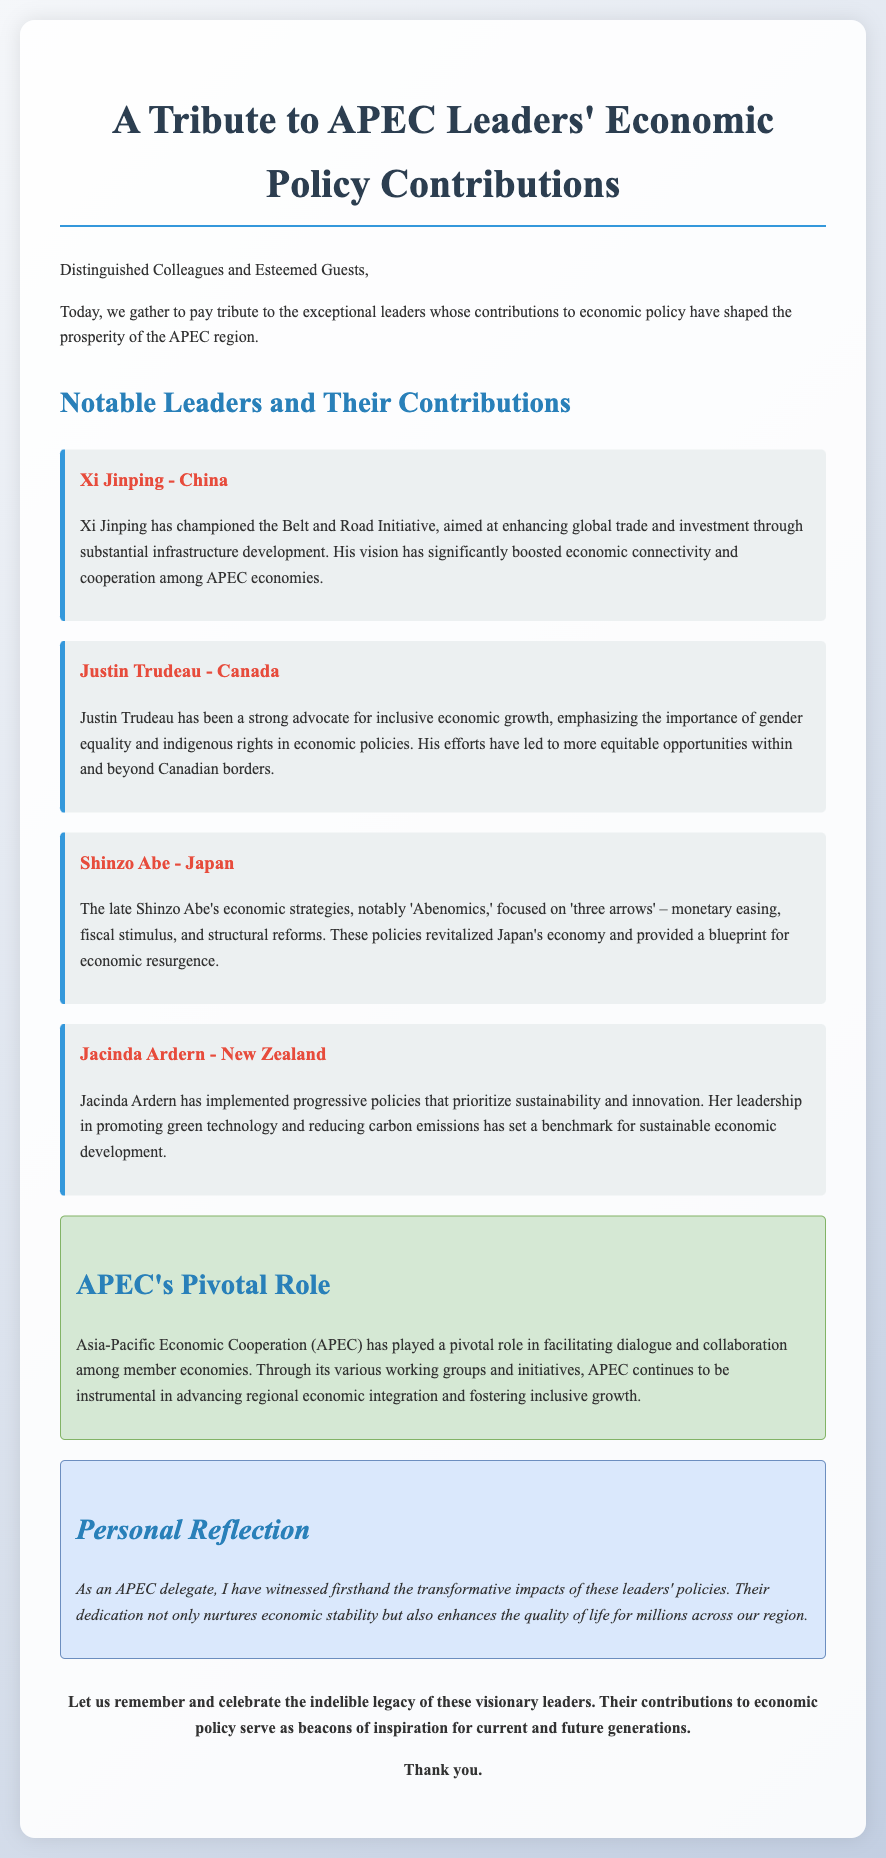What is the title of the document? The title is presented prominently at the top of the document, summarizing its purpose and focus.
Answer: A Tribute to APEC Leaders' Economic Policy Contributions Who has championed the Belt and Road Initiative? This information is found in the section discussing notable leaders and their contributions.
Answer: Xi Jinping What economic strategy is associated with Shinzo Abe? This strategy is specifically mentioned in relation to Shinzo Abe's policies described in the document.
Answer: Abenomics Which leader emphasized gender equality in economic policies? The document explicitly details the contributions of leaders to economic policy, including this aspect.
Answer: Justin Trudeau What is APEC's role in regional economic integration? The document outlines APEC's importance in facilitating collaboration among member economies.
Answer: Pivotal What are the "three arrows" mentioned in connection with Shinzo Abe? The document refers to these arrows as part of the explanation of Abenomics.
Answer: Monetary easing, fiscal stimulus, structural reforms What is a key focus of Jacinda Ardern’s policies? The document highlights her progressive policies aimed at a specific goal regarding economic development.
Answer: Sustainability How does the document classify the reflection section? The classification is indicated by the section's title and content that provides personal insights.
Answer: Personal Reflection 